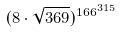Convert formula to latex. <formula><loc_0><loc_0><loc_500><loc_500>( 8 \cdot \sqrt { 3 6 9 } ) ^ { 1 6 6 ^ { 3 1 5 } }</formula> 